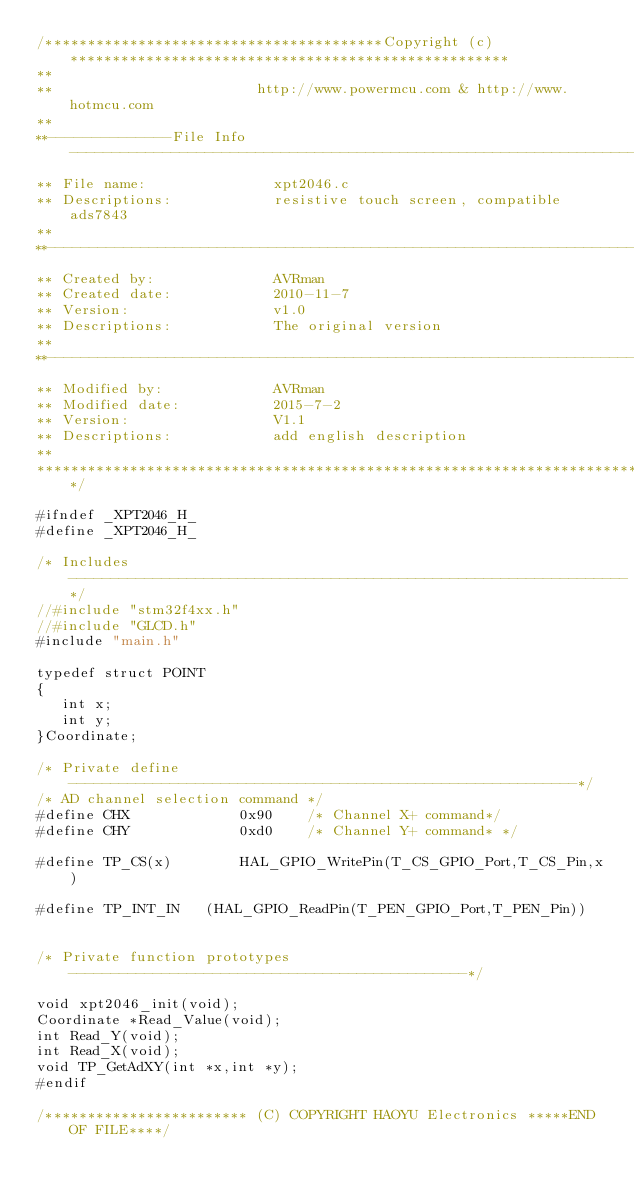Convert code to text. <code><loc_0><loc_0><loc_500><loc_500><_C_>/****************************************Copyright (c)****************************************************
**                                      
**                        http://www.powermcu.com & http://www.hotmcu.com
**
**--------------File Info---------------------------------------------------------------------------------
** File name:               xpt2046.c
** Descriptions:            resistive touch screen, compatible ads7843
**
**--------------------------------------------------------------------------------------------------------
** Created by:              AVRman
** Created date:            2010-11-7
** Version:                 v1.0
** Descriptions:            The original version
**
**--------------------------------------------------------------------------------------------------------
** Modified by:             AVRman
** Modified date:           2015-7-2
** Version:                 V1.1
** Descriptions:            add english description
**
*********************************************************************************************************/

#ifndef _XPT2046_H_
#define _XPT2046_H_

/* Includes ------------------------------------------------------------------*/
//#include "stm32f4xx.h"
//#include "GLCD.h" 
#include "main.h"

typedef	struct POINT 
{
   int x;
   int y;
}Coordinate;

/* Private define ------------------------------------------------------------*/
/* AD channel selection command */
#define	CHX 	        0x90 	/* Channel X+ command*/	
#define	CHY 	        0xd0	/* Channel Y+ command* */

#define TP_CS(x)		HAL_GPIO_WritePin(T_CS_GPIO_Port,T_CS_Pin,x)

#define TP_INT_IN   (HAL_GPIO_ReadPin(T_PEN_GPIO_Port,T_PEN_Pin))


/* Private function prototypes -----------------------------------------------*/				
void xpt2046_init(void);	
Coordinate *Read_Value(void);
int Read_Y(void);
int Read_X(void);
void TP_GetAdXY(int *x,int *y);
#endif

/************************ (C) COPYRIGHT HAOYU Electronics *****END OF FILE****/
</code> 